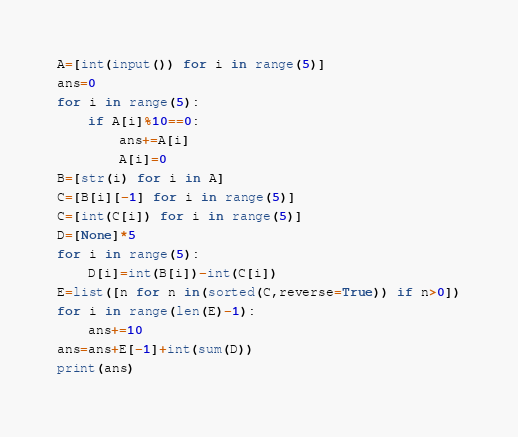Convert code to text. <code><loc_0><loc_0><loc_500><loc_500><_Python_>A=[int(input()) for i in range(5)]
ans=0
for i in range(5):
    if A[i]%10==0:
        ans+=A[i]
        A[i]=0
B=[str(i) for i in A]
C=[B[i][-1] for i in range(5)]
C=[int(C[i]) for i in range(5)]
D=[None]*5
for i in range(5):
    D[i]=int(B[i])-int(C[i])
E=list([n for n in(sorted(C,reverse=True)) if n>0])
for i in range(len(E)-1):
    ans+=10
ans=ans+E[-1]+int(sum(D))
print(ans)</code> 